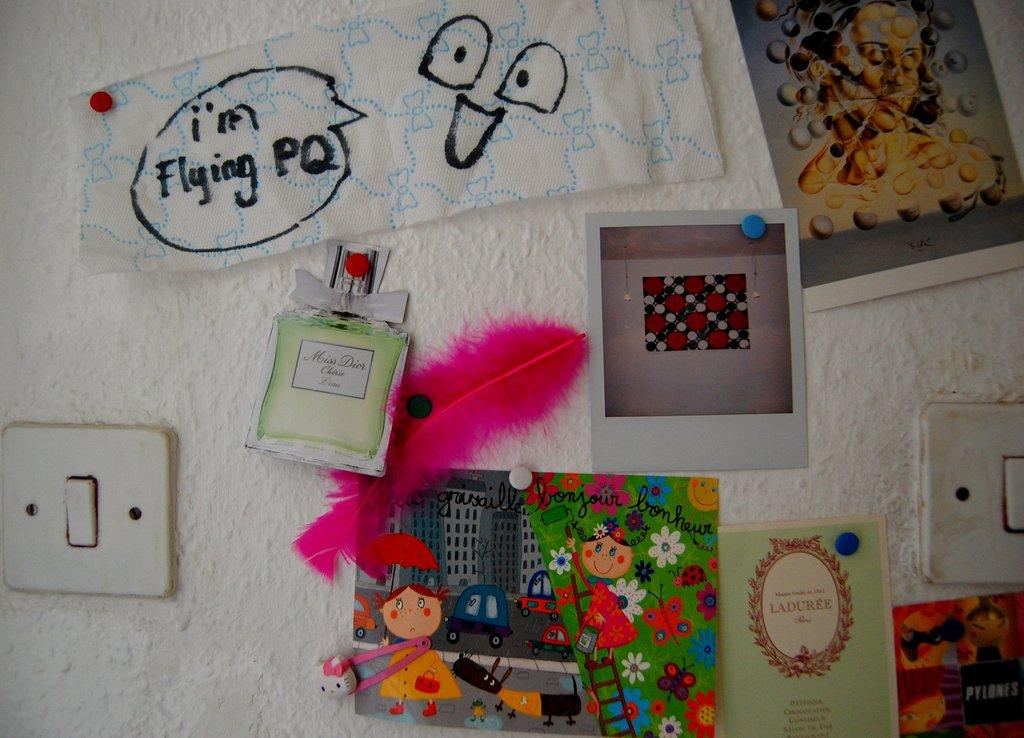What's written on the paper?
Your response must be concise. I'm flying pq. What does the card on the bottom right say?
Ensure brevity in your answer.  Laduree. 